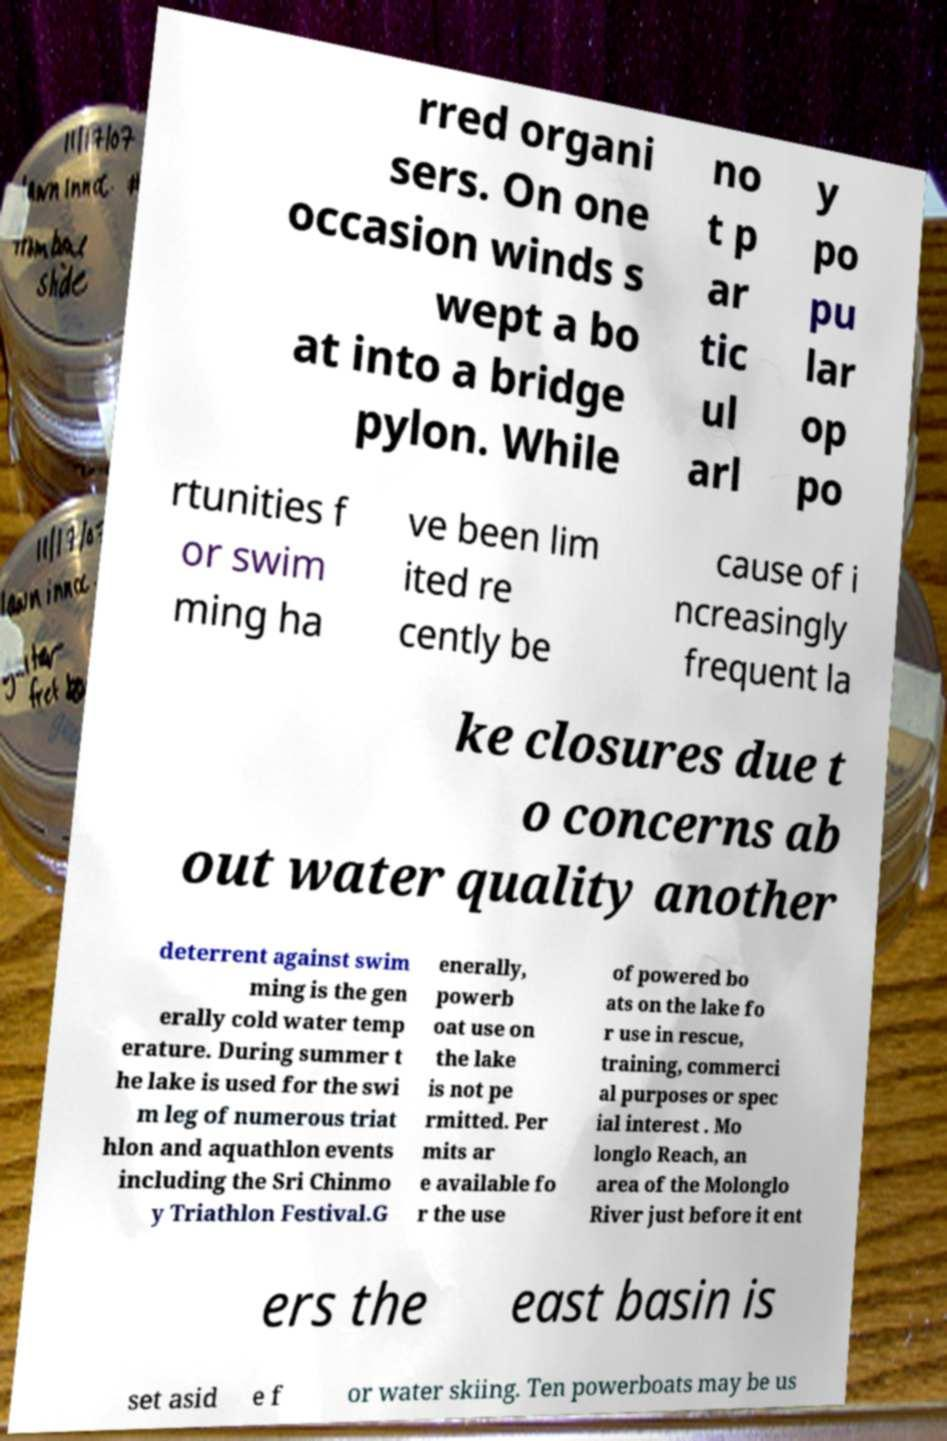For documentation purposes, I need the text within this image transcribed. Could you provide that? rred organi sers. On one occasion winds s wept a bo at into a bridge pylon. While no t p ar tic ul arl y po pu lar op po rtunities f or swim ming ha ve been lim ited re cently be cause of i ncreasingly frequent la ke closures due t o concerns ab out water quality another deterrent against swim ming is the gen erally cold water temp erature. During summer t he lake is used for the swi m leg of numerous triat hlon and aquathlon events including the Sri Chinmo y Triathlon Festival.G enerally, powerb oat use on the lake is not pe rmitted. Per mits ar e available fo r the use of powered bo ats on the lake fo r use in rescue, training, commerci al purposes or spec ial interest . Mo longlo Reach, an area of the Molonglo River just before it ent ers the east basin is set asid e f or water skiing. Ten powerboats may be us 